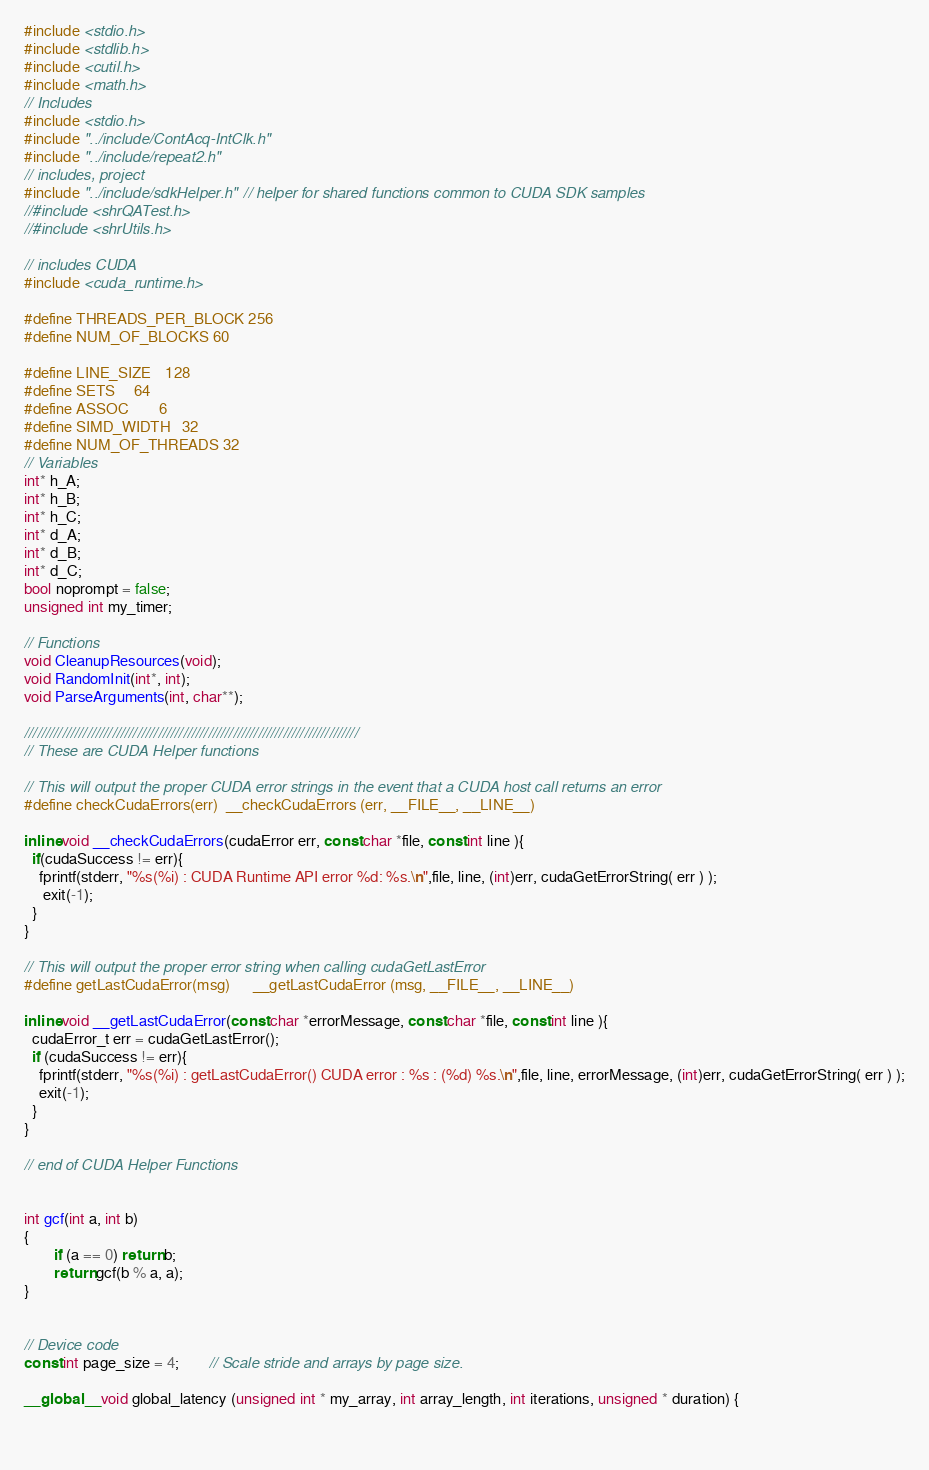<code> <loc_0><loc_0><loc_500><loc_500><_Cuda_>#include <stdio.h>
#include <stdlib.h>
#include <cutil.h>
#include <math.h>
// Includes
#include <stdio.h>
#include "../include/ContAcq-IntClk.h"
#include "../include/repeat2.h"
// includes, project
#include "../include/sdkHelper.h"  // helper for shared functions common to CUDA SDK samples
//#include <shrQATest.h>
//#include <shrUtils.h>

// includes CUDA
#include <cuda_runtime.h>

#define THREADS_PER_BLOCK 256
#define NUM_OF_BLOCKS 60

#define LINE_SIZE 	128
#define SETS		64
#define ASSOC		6
#define SIMD_WIDTH	32
#define NUM_OF_THREADS 32
// Variables
int* h_A;
int* h_B;
int* h_C;
int* d_A;
int* d_B;
int* d_C;
bool noprompt = false;
unsigned int my_timer;

// Functions
void CleanupResources(void);
void RandomInit(int*, int);
void ParseArguments(int, char**);

////////////////////////////////////////////////////////////////////////////////
// These are CUDA Helper functions

// This will output the proper CUDA error strings in the event that a CUDA host call returns an error
#define checkCudaErrors(err)  __checkCudaErrors (err, __FILE__, __LINE__)

inline void __checkCudaErrors(cudaError err, const char *file, const int line ){
  if(cudaSuccess != err){
	fprintf(stderr, "%s(%i) : CUDA Runtime API error %d: %s.\n",file, line, (int)err, cudaGetErrorString( err ) );
	 exit(-1);
  }
}

// This will output the proper error string when calling cudaGetLastError
#define getLastCudaError(msg)      __getLastCudaError (msg, __FILE__, __LINE__)

inline void __getLastCudaError(const char *errorMessage, const char *file, const int line ){
  cudaError_t err = cudaGetLastError();
  if (cudaSuccess != err){
	fprintf(stderr, "%s(%i) : getLastCudaError() CUDA error : %s : (%d) %s.\n",file, line, errorMessage, (int)err, cudaGetErrorString( err ) );
	exit(-1);
  }
}

// end of CUDA Helper Functions


int gcf(int a, int b)
{
        if (a == 0) return b;
        return gcf(b % a, a);
}


// Device code
const int page_size = 4;        // Scale stride and arrays by page size.

__global__ void global_latency (unsigned int * my_array, int array_length, int iterations, unsigned * duration) {

    </code> 